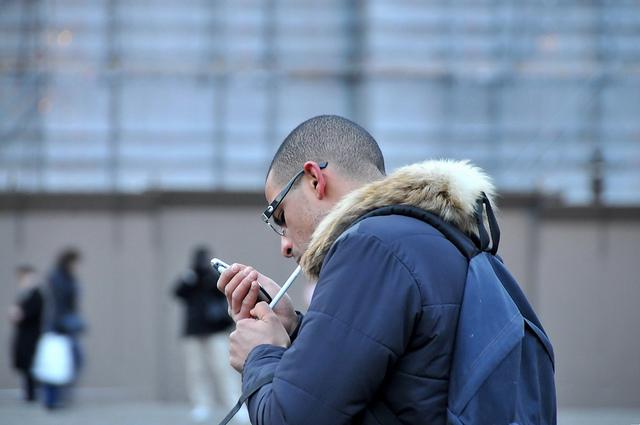Is this man smoking?
Give a very brief answer. Yes. What is the man holding?
Answer briefly. Cigarette. Is this person healthy?
Give a very brief answer. No. 